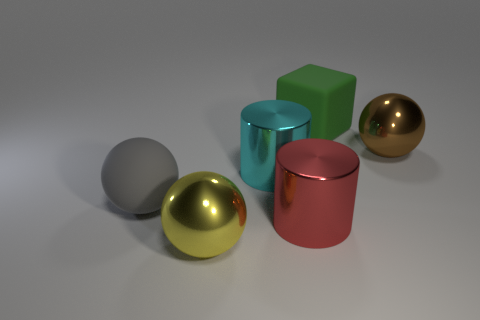The large cylinder that is in front of the big gray rubber sphere is what color?
Offer a terse response. Red. Is the number of gray rubber things less than the number of tiny yellow metallic balls?
Offer a terse response. No. There is a large gray rubber ball; how many yellow metallic balls are in front of it?
Ensure brevity in your answer.  1. Is the large gray matte thing the same shape as the green thing?
Your answer should be very brief. No. What number of big objects are both in front of the brown ball and behind the large brown metallic sphere?
Keep it short and to the point. 0. How many things are either tiny green shiny blocks or large shiny things that are in front of the large brown ball?
Provide a short and direct response. 3. Are there more big red cylinders than big cyan metal cubes?
Your answer should be very brief. Yes. There is a rubber thing right of the yellow metallic thing; what shape is it?
Your response must be concise. Cube. What number of cyan objects are the same shape as the yellow shiny thing?
Offer a terse response. 0. There is a shiny ball that is on the left side of the metallic ball to the right of the green block; what is its size?
Offer a very short reply. Large. 